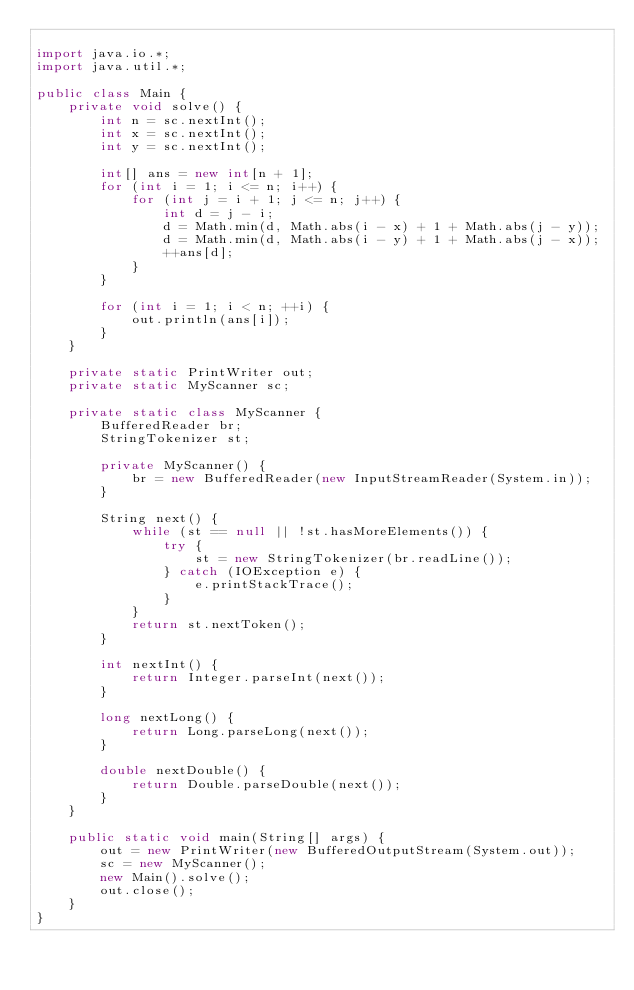<code> <loc_0><loc_0><loc_500><loc_500><_Java_>
import java.io.*;
import java.util.*;

public class Main {
    private void solve() {
        int n = sc.nextInt();
        int x = sc.nextInt();
        int y = sc.nextInt();

        int[] ans = new int[n + 1];
        for (int i = 1; i <= n; i++) {
            for (int j = i + 1; j <= n; j++) {
                int d = j - i;
                d = Math.min(d, Math.abs(i - x) + 1 + Math.abs(j - y));
                d = Math.min(d, Math.abs(i - y) + 1 + Math.abs(j - x));
                ++ans[d];
            }
        }

        for (int i = 1; i < n; ++i) {
            out.println(ans[i]);
        }
    }

    private static PrintWriter out;
    private static MyScanner sc;

    private static class MyScanner {
        BufferedReader br;
        StringTokenizer st;

        private MyScanner() {
            br = new BufferedReader(new InputStreamReader(System.in));
        }

        String next() {
            while (st == null || !st.hasMoreElements()) {
                try {
                    st = new StringTokenizer(br.readLine());
                } catch (IOException e) {
                    e.printStackTrace();
                }
            }
            return st.nextToken();
        }

        int nextInt() {
            return Integer.parseInt(next());
        }

        long nextLong() {
            return Long.parseLong(next());
        }

        double nextDouble() {
            return Double.parseDouble(next());
        }
    }

    public static void main(String[] args) {
        out = new PrintWriter(new BufferedOutputStream(System.out));
        sc = new MyScanner();
        new Main().solve();
        out.close();
    }
}
</code> 